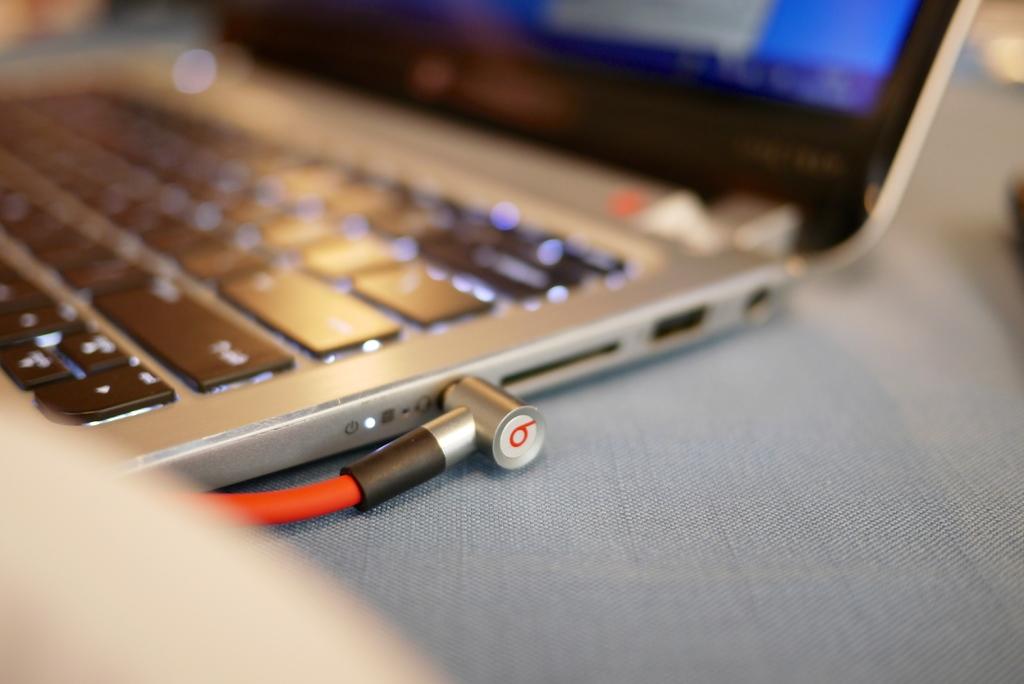What is the letter shown on the cord?
Offer a very short reply. B. Is that the enter button?
Provide a short and direct response. Yes. 